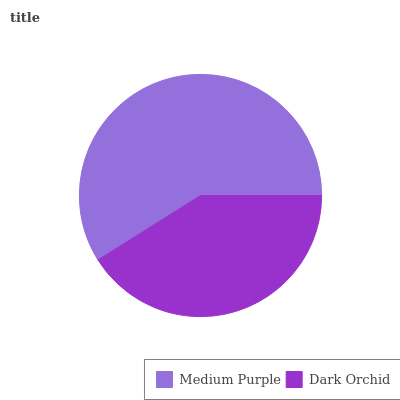Is Dark Orchid the minimum?
Answer yes or no. Yes. Is Medium Purple the maximum?
Answer yes or no. Yes. Is Dark Orchid the maximum?
Answer yes or no. No. Is Medium Purple greater than Dark Orchid?
Answer yes or no. Yes. Is Dark Orchid less than Medium Purple?
Answer yes or no. Yes. Is Dark Orchid greater than Medium Purple?
Answer yes or no. No. Is Medium Purple less than Dark Orchid?
Answer yes or no. No. Is Medium Purple the high median?
Answer yes or no. Yes. Is Dark Orchid the low median?
Answer yes or no. Yes. Is Dark Orchid the high median?
Answer yes or no. No. Is Medium Purple the low median?
Answer yes or no. No. 